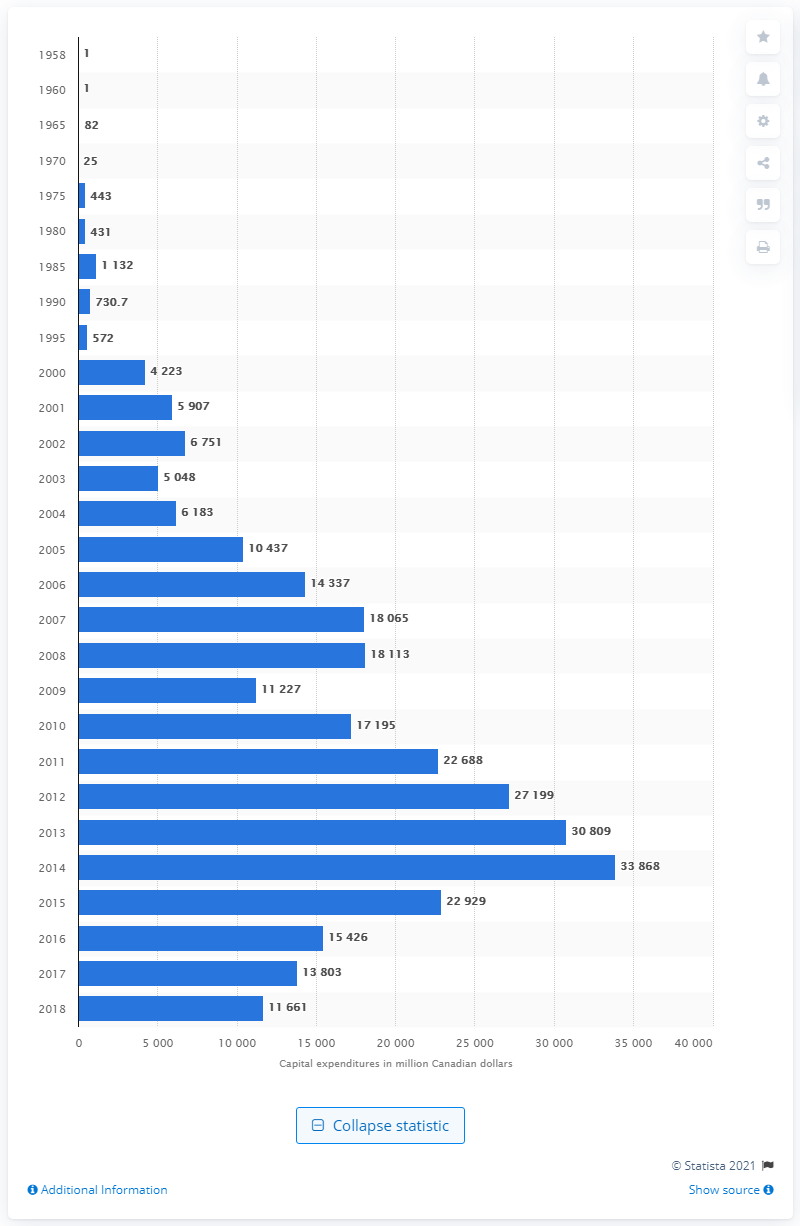Identify some key points in this picture. The capital expenditures of Canada's oil sands industry in 1958 were $1 million. In 2018, the capital expenditure of Canada's oil sands industry was approximately 11,227. 